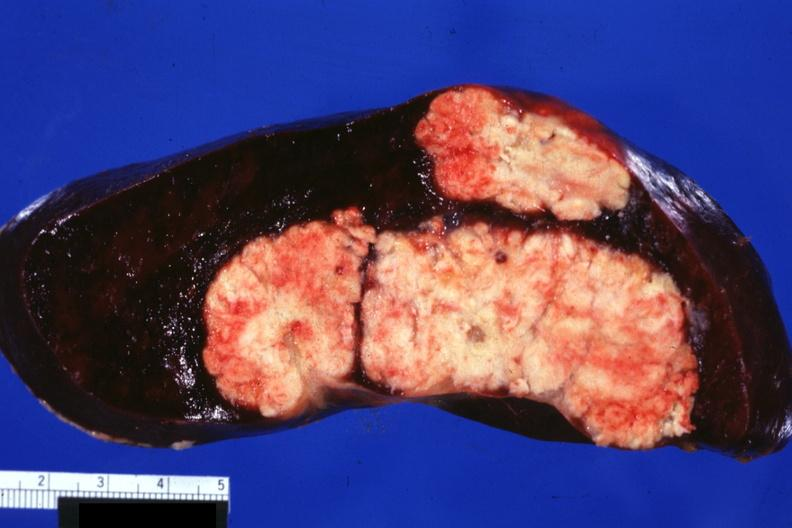what is present?
Answer the question using a single word or phrase. Hematologic 